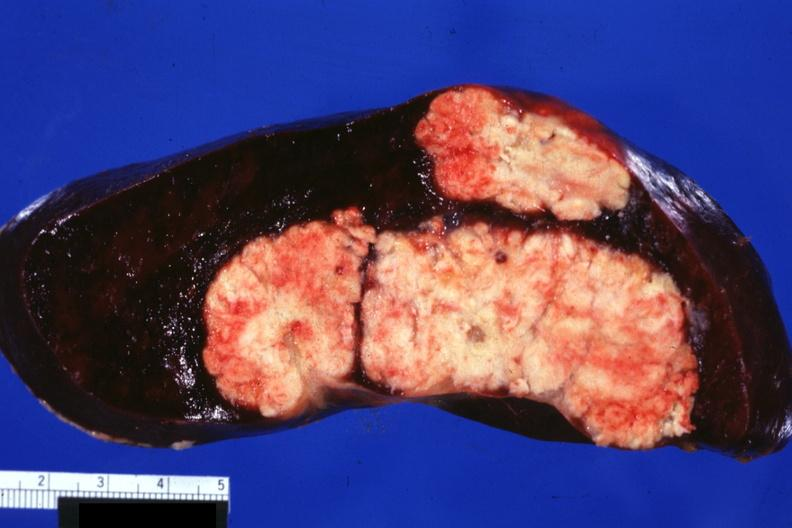what is present?
Answer the question using a single word or phrase. Hematologic 